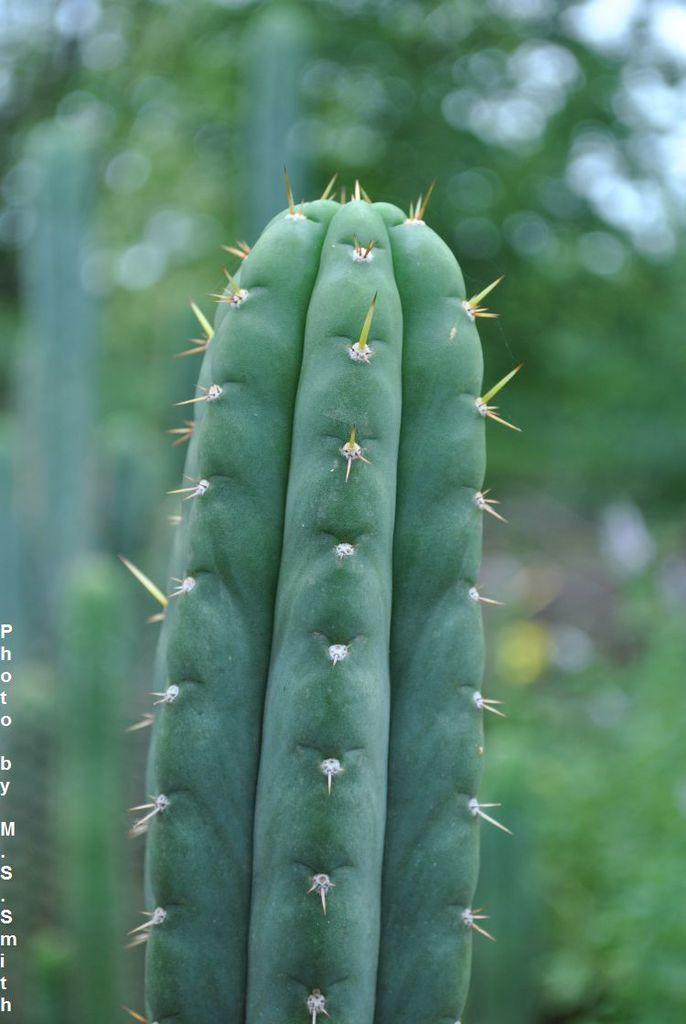What type of plant is in the image? There is a cactus plant in the image. Can you describe the background of the image? The background of the image is blurry. What is located on the left side of the image? There is text on the left side of the image. Is there a wristwatch visible on the cactus plant in the image? No, there is no wristwatch present on the cactus plant in the image. 